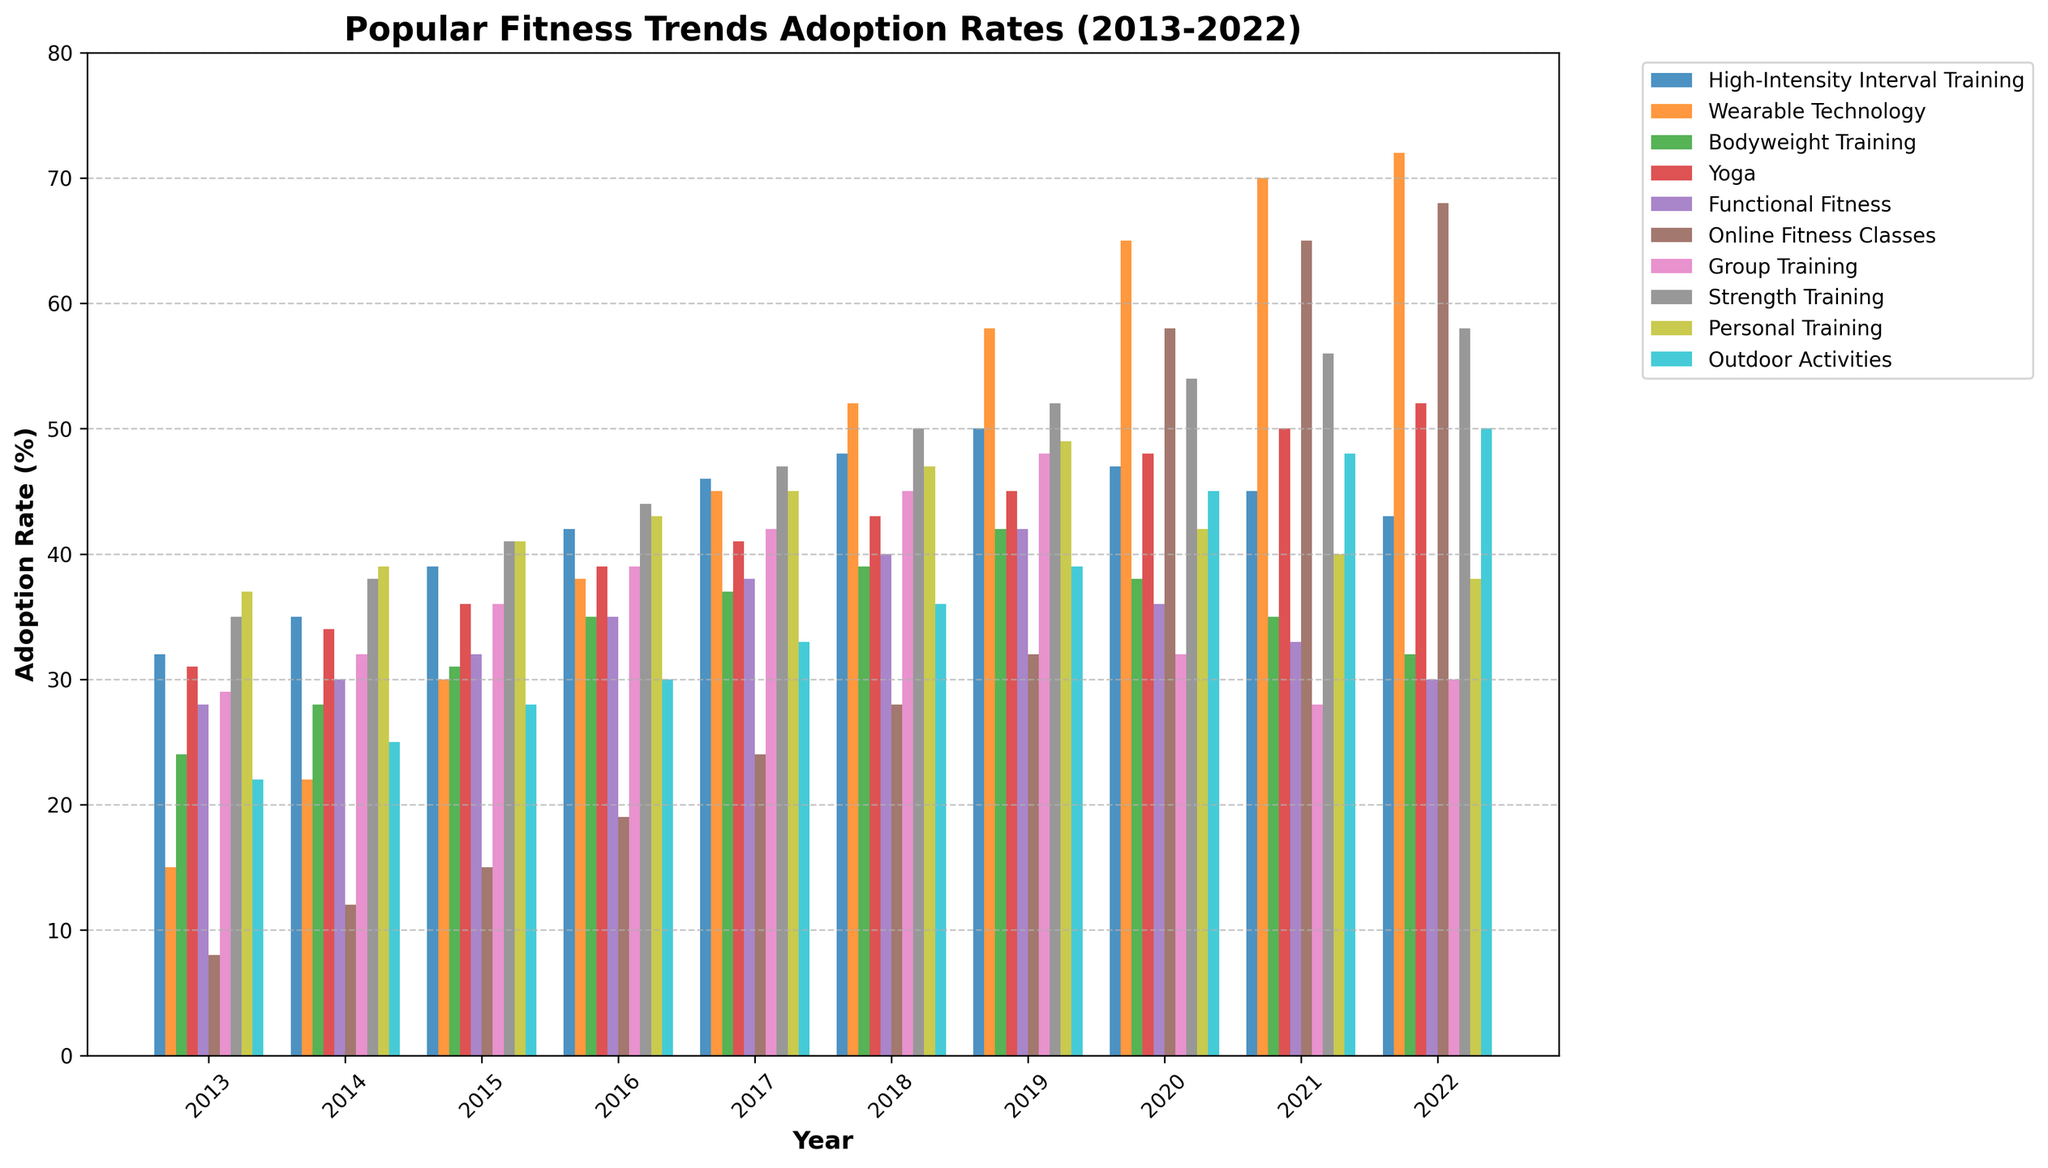Which fitness trend had the highest adoption rate in 2022? By looking at the bars corresponding to each trend in 2022, the bar for Wearable Technology is the tallest.
Answer: Wearable Technology How did the adoption rate of Online Fitness Classes change from 2019 to 2020? Compare the height of the bars for Online Fitness Classes in 2019 and 2020. The bar in 2020 is significantly higher.
Answer: Increased Which year saw the highest adoption rate for High-Intensity Interval Training (HIIT)? Check the bars for HIIT across all years and identify the tallest one. The tallest bar for HIIT is in 2019.
Answer: 2019 What is the difference in adoption rates of Personal Training between 2013 and 2022? Subtract the height of the Personal Training bar in 2013 from the height in 2022.
Answer: -1 (37 - 38) Which fitness trend had a declining adoption rate from 2019 to 2021? Identify trends whose bars decrease in height from 2019 through 2021. Group Training's bars declined from 48 in 2019 to 42 in 2021 to 28 in 2022.
Answer: Group Training What is the average adoption rate of Functional Fitness over the past decade? Sum the adoption rates of Functional Fitness for all years and divide by the number of years (10). (28+30+32+35+38+40+42+36+33+30) / 10 = 34.4
Answer: 34.4 Which three years saw the highest growth in adoption rate for Wearable Technology? Observe the slopes of the Wearable Technology bars between consecutive years. The highest growths are between 2016-2017, 2017-2018, and 2018-2019.
Answer: 2016-2017, 2017-2018, 2018-2019 Compare the adoption rates of Yoga and Bodyweight Training in 2020. Which one is higher? Look at the bars for Yoga and Bodyweight Training in 2020 and compare their heights. The Yoga bar is taller.
Answer: Yoga What is the combined adoption rate of Outdoor Activities and Strength Training in 2022? Add the heights of the bars for Outdoor Activities and Strength Training in 2022. 50 + 58 = 108
Answer: 108 Which trend showed a significant increase in 2020 compared to 2019, possibly due to the pandemic? Check bars with a noticeable rise in 2020 compared to 2019. Online Fitness Classes' adoption rate spiked from 32 in 2019 to 58 in 2020.
Answer: Online Fitness Classes 